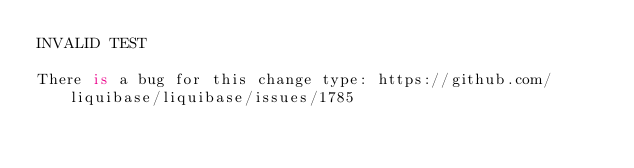<code> <loc_0><loc_0><loc_500><loc_500><_SQL_>INVALID TEST

There is a bug for this change type: https://github.com/liquibase/liquibase/issues/1785</code> 